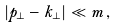<formula> <loc_0><loc_0><loc_500><loc_500>| { p } _ { \perp } - { k } _ { \perp } | \ll m \, ,</formula> 